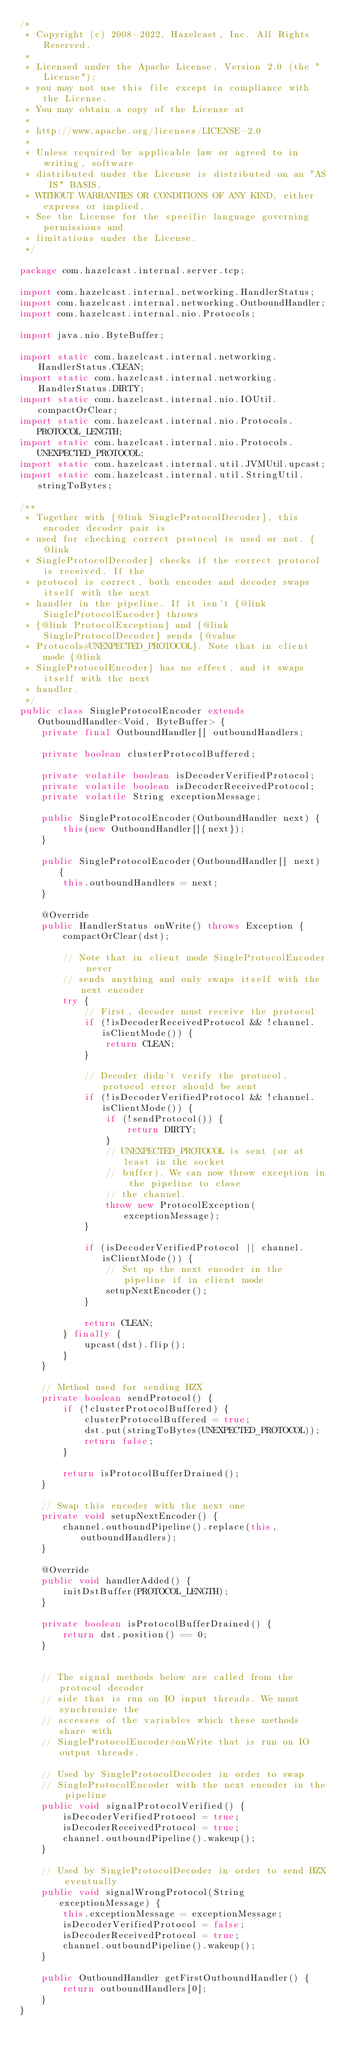Convert code to text. <code><loc_0><loc_0><loc_500><loc_500><_Java_>/*
 * Copyright (c) 2008-2022, Hazelcast, Inc. All Rights Reserved.
 *
 * Licensed under the Apache License, Version 2.0 (the "License");
 * you may not use this file except in compliance with the License.
 * You may obtain a copy of the License at
 *
 * http://www.apache.org/licenses/LICENSE-2.0
 *
 * Unless required by applicable law or agreed to in writing, software
 * distributed under the License is distributed on an "AS IS" BASIS,
 * WITHOUT WARRANTIES OR CONDITIONS OF ANY KIND, either express or implied.
 * See the License for the specific language governing permissions and
 * limitations under the License.
 */

package com.hazelcast.internal.server.tcp;

import com.hazelcast.internal.networking.HandlerStatus;
import com.hazelcast.internal.networking.OutboundHandler;
import com.hazelcast.internal.nio.Protocols;

import java.nio.ByteBuffer;

import static com.hazelcast.internal.networking.HandlerStatus.CLEAN;
import static com.hazelcast.internal.networking.HandlerStatus.DIRTY;
import static com.hazelcast.internal.nio.IOUtil.compactOrClear;
import static com.hazelcast.internal.nio.Protocols.PROTOCOL_LENGTH;
import static com.hazelcast.internal.nio.Protocols.UNEXPECTED_PROTOCOL;
import static com.hazelcast.internal.util.JVMUtil.upcast;
import static com.hazelcast.internal.util.StringUtil.stringToBytes;

/**
 * Together with {@link SingleProtocolDecoder}, this encoder decoder pair is
 * used for checking correct protocol is used or not. {@link
 * SingleProtocolDecoder} checks if the correct protocol is received. If the
 * protocol is correct, both encoder and decoder swaps itself with the next
 * handler in the pipeline. If it isn't {@link SingleProtocolEncoder} throws
 * {@link ProtocolException} and {@link SingleProtocolDecoder} sends {@value
 * Protocols#UNEXPECTED_PROTOCOL}. Note that in client mode {@link
 * SingleProtocolEncoder} has no effect, and it swaps itself with the next
 * handler.
 */
public class SingleProtocolEncoder extends OutboundHandler<Void, ByteBuffer> {
    private final OutboundHandler[] outboundHandlers;

    private boolean clusterProtocolBuffered;

    private volatile boolean isDecoderVerifiedProtocol;
    private volatile boolean isDecoderReceivedProtocol;
    private volatile String exceptionMessage;

    public SingleProtocolEncoder(OutboundHandler next) {
        this(new OutboundHandler[]{next});
    }

    public SingleProtocolEncoder(OutboundHandler[] next) {
        this.outboundHandlers = next;
    }

    @Override
    public HandlerStatus onWrite() throws Exception {
        compactOrClear(dst);

        // Note that in client mode SingleProtocolEncoder never
        // sends anything and only swaps itself with the next encoder
        try {
            // First, decoder must receive the protocol
            if (!isDecoderReceivedProtocol && !channel.isClientMode()) {
                return CLEAN;
            }

            // Decoder didn't verify the protocol, protocol error should be sent
            if (!isDecoderVerifiedProtocol && !channel.isClientMode()) {
                if (!sendProtocol()) {
                    return DIRTY;
                }
                // UNEXPECTED_PROTOCOL is sent (or at least in the socket
                // buffer). We can now throw exception in the pipeline to close
                // the channel.
                throw new ProtocolException(exceptionMessage);
            }

            if (isDecoderVerifiedProtocol || channel.isClientMode()) {
                // Set up the next encoder in the pipeline if in client mode
                setupNextEncoder();
            }

            return CLEAN;
        } finally {
            upcast(dst).flip();
        }
    }

    // Method used for sending HZX
    private boolean sendProtocol() {
        if (!clusterProtocolBuffered) {
            clusterProtocolBuffered = true;
            dst.put(stringToBytes(UNEXPECTED_PROTOCOL));
            return false;
        }

        return isProtocolBufferDrained();
    }

    // Swap this encoder with the next one
    private void setupNextEncoder() {
        channel.outboundPipeline().replace(this, outboundHandlers);
    }

    @Override
    public void handlerAdded() {
        initDstBuffer(PROTOCOL_LENGTH);
    }

    private boolean isProtocolBufferDrained() {
        return dst.position() == 0;
    }


    // The signal methods below are called from the protocol decoder
    // side that is run on IO input threads. We must synchronize the
    // accesses of the variables which these methods share with
    // SingleProtocolEncoder#onWrite that is run on IO output threads.

    // Used by SingleProtocolDecoder in order to swap
    // SingleProtocolEncoder with the next encoder in the pipeline
    public void signalProtocolVerified() {
        isDecoderVerifiedProtocol = true;
        isDecoderReceivedProtocol = true;
        channel.outboundPipeline().wakeup();
    }

    // Used by SingleProtocolDecoder in order to send HZX eventually
    public void signalWrongProtocol(String exceptionMessage) {
        this.exceptionMessage = exceptionMessage;
        isDecoderVerifiedProtocol = false;
        isDecoderReceivedProtocol = true;
        channel.outboundPipeline().wakeup();
    }

    public OutboundHandler getFirstOutboundHandler() {
        return outboundHandlers[0];
    }
}
</code> 